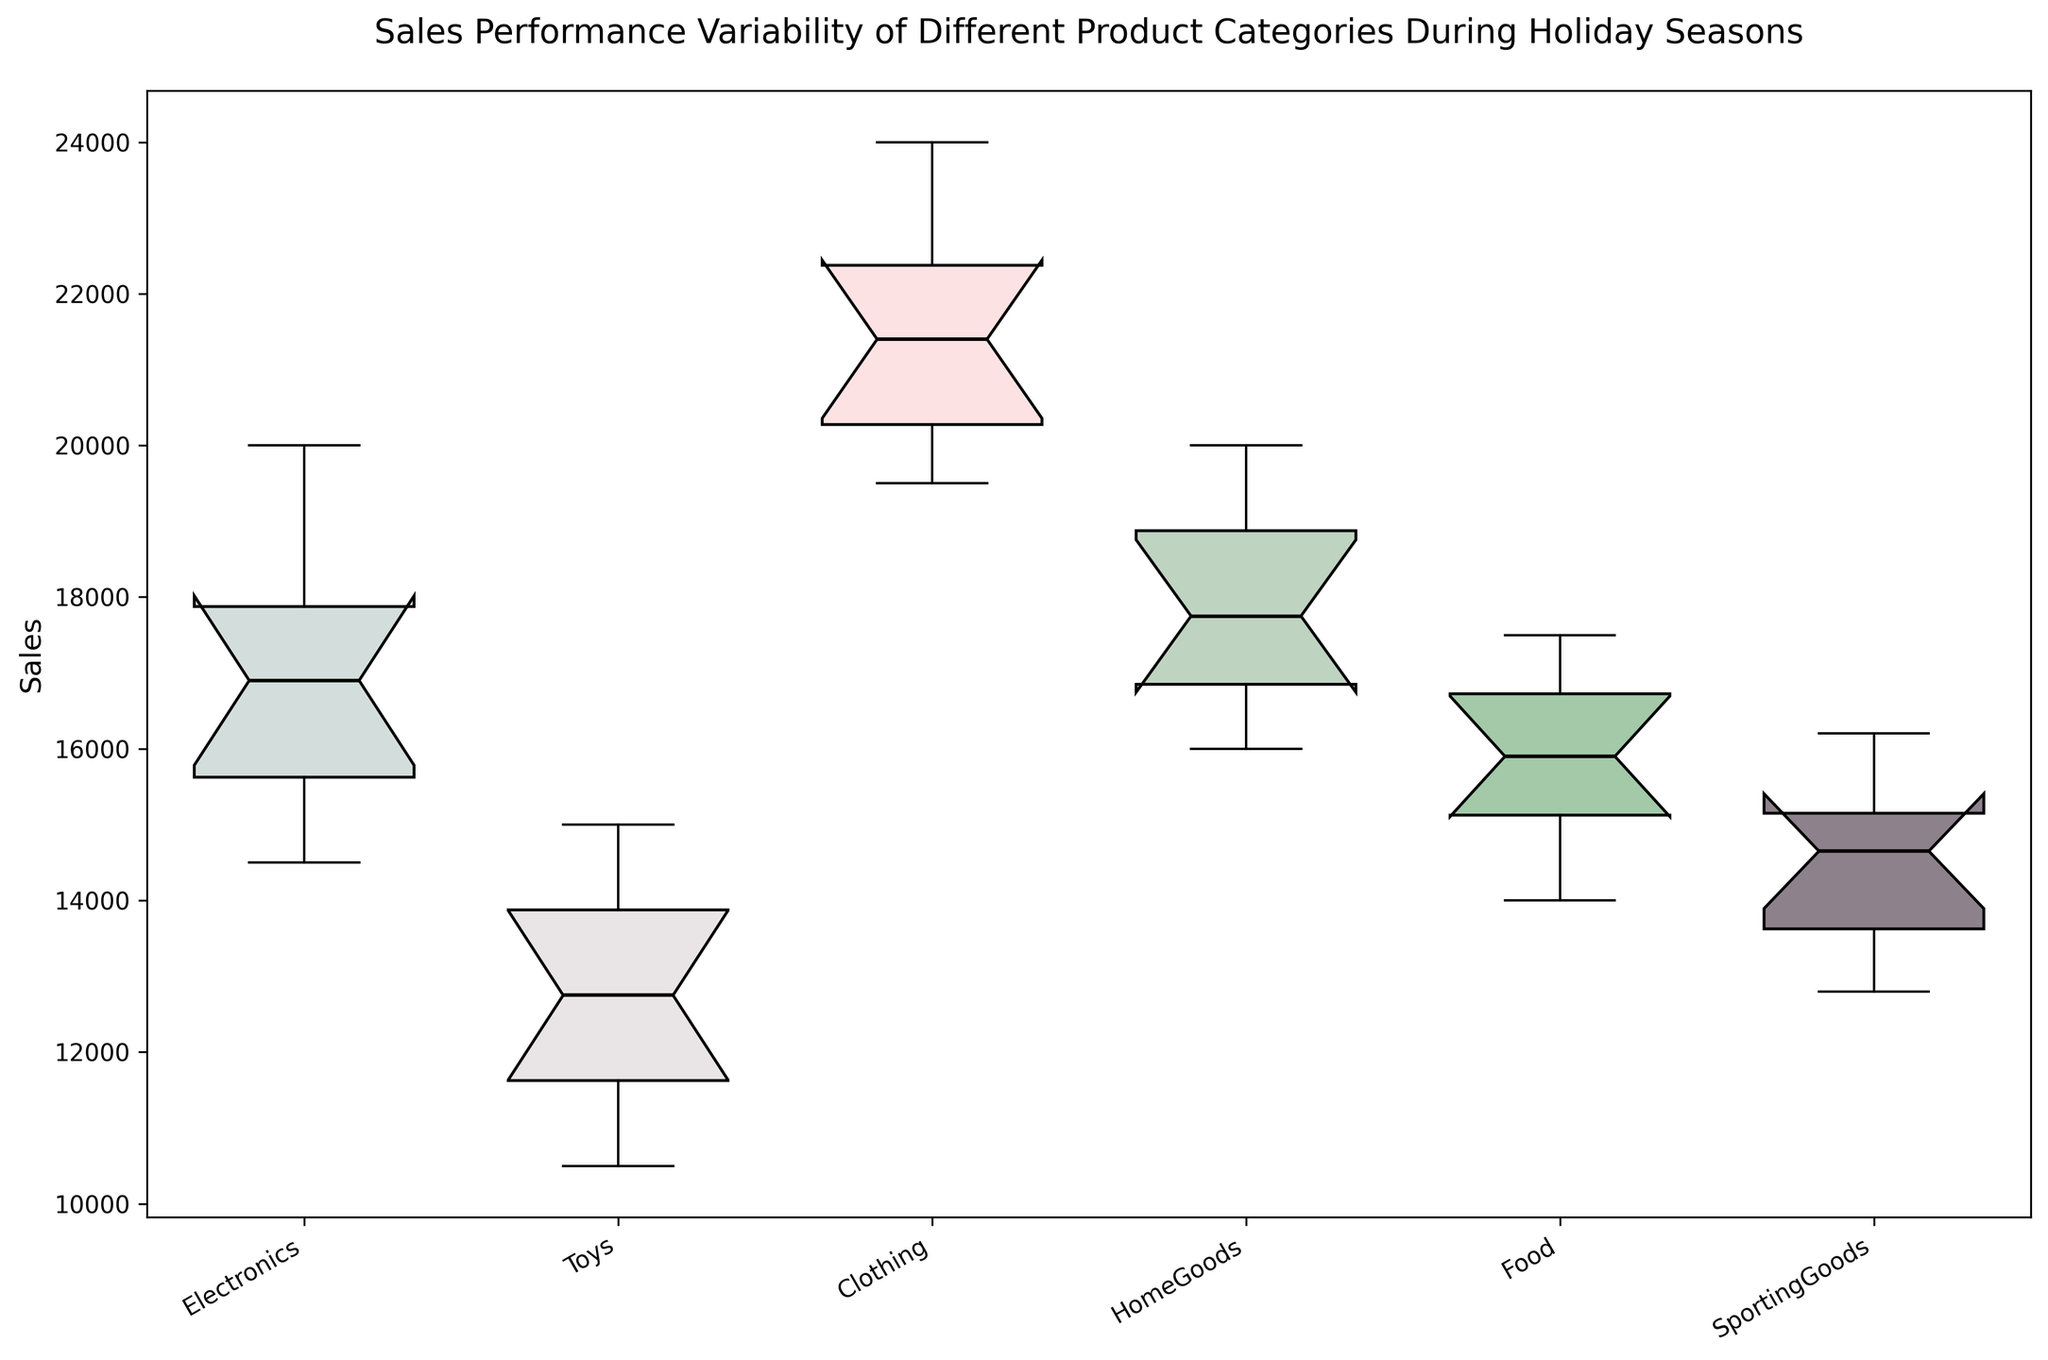What is the median sales value for the Electronics category? Find the box plot for the Electronics category, locate the median line inside the box, and read the value of the median.
Answer: 16800 Which product category has the highest median sales value? Compare the position of the median lines (inside the boxes) of all product categories. The category with the highest median line represents the highest median sales value.
Answer: Clothing Which category shows the largest range in sales (distance between the top and bottom whiskers)? Locate the whiskers (the lines extending from the top and bottom of the boxes) and measure the length between the top and bottom whisker for each category. Identify the category with the longest whisker span.
Answer: Clothing How does the interquartile range (IQR) of Toys sales compare to the IQR of Food sales? The IQR is the range of values between the first quartile (bottom of the box) and the third quartile (top of the box). Measure the height of the boxes for Toys and Food and compare the two.
Answer: The IQR of Toys is smaller than the IQR of Food What is the difference between the highest and lowest sales values for the HomeGoods category? Identify the top and bottom whiskers of the HomeGoods box plot to locate the highest and lowest sales values. Subtract the lowest value from the highest value.
Answer: 6000 Which category has the smallest spread (distance between the first and third quartiles) in sales? The spread is the height of the box. Compare the heights of the boxes for all categories and identify the smallest one.
Answer: Electronics Is the median sales value for SportingGoods higher than that for Toys? Compare the median lines (inside the boxes) of SportingGoods and Toys. Identify which median line is higher.
Answer: No Which product category has the greatest variability in sales? Variability can be visually assessed by the overall height of the plot (whiskers and box combined). Compare the total heights of all categories and identify the largest one.
Answer: Clothing 